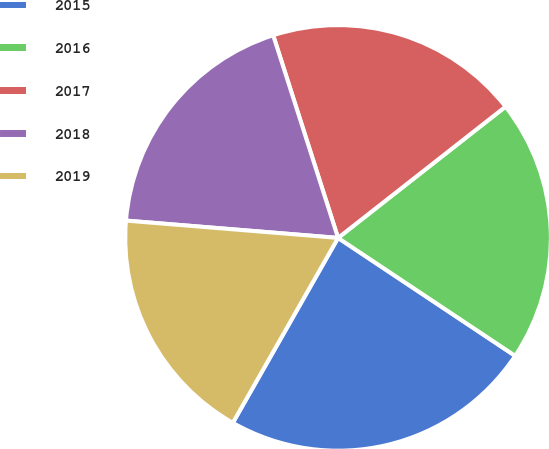Convert chart. <chart><loc_0><loc_0><loc_500><loc_500><pie_chart><fcel>2015<fcel>2016<fcel>2017<fcel>2018<fcel>2019<nl><fcel>23.88%<fcel>19.93%<fcel>19.35%<fcel>18.77%<fcel>18.06%<nl></chart> 